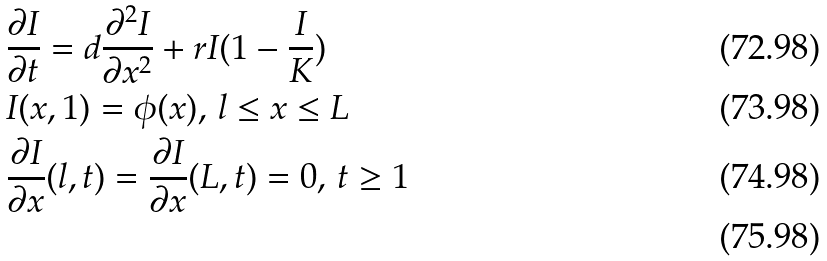Convert formula to latex. <formula><loc_0><loc_0><loc_500><loc_500>& \frac { \partial I } { \partial t } = d \frac { \partial ^ { 2 } I } { \partial x ^ { 2 } } + r I ( 1 - \frac { I } { K } ) \\ & I ( x , 1 ) = \phi ( x ) , \, l \leq x \leq L \\ & \frac { \partial I } { \partial x } ( l , t ) = \frac { \partial I } { \partial x } ( L , t ) = 0 , \, t \geq 1 \\</formula> 